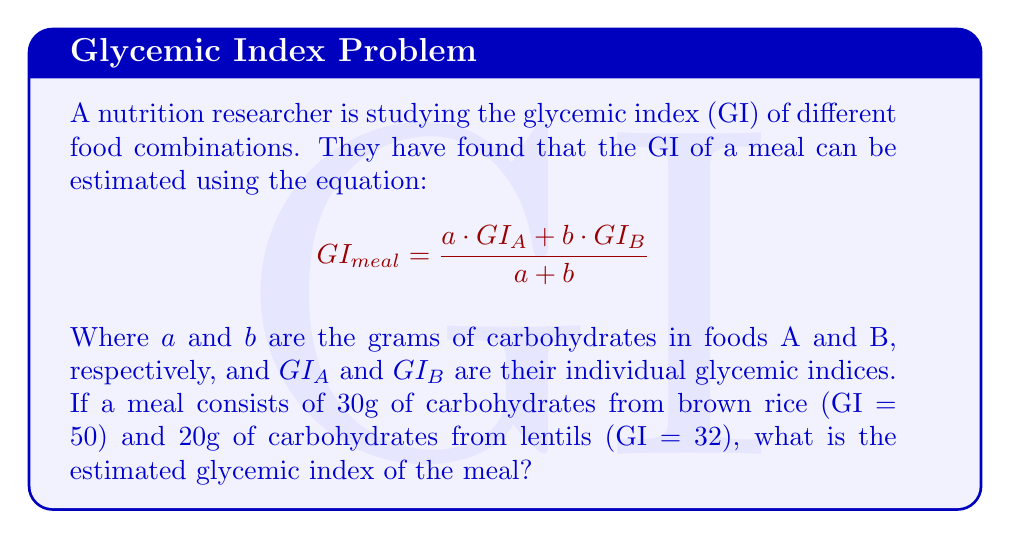Show me your answer to this math problem. Let's approach this step-by-step:

1) We are given the equation:
   $$GI_{meal} = \frac{a \cdot GI_A + b \cdot GI_B}{a + b}$$

2) We know the following:
   - Food A is brown rice: $a = 30g$, $GI_A = 50$
   - Food B is lentils: $b = 20g$, $GI_B = 32$

3) Let's substitute these values into our equation:
   $$GI_{meal} = \frac{30 \cdot 50 + 20 \cdot 32}{30 + 20}$$

4) Now, let's solve the numerator:
   $$GI_{meal} = \frac{1500 + 640}{50}$$
   $$GI_{meal} = \frac{2140}{50}$$

5) Finally, let's divide:
   $$GI_{meal} = 42.8$$

Therefore, the estimated glycemic index of the meal is 42.8.
Answer: 42.8 